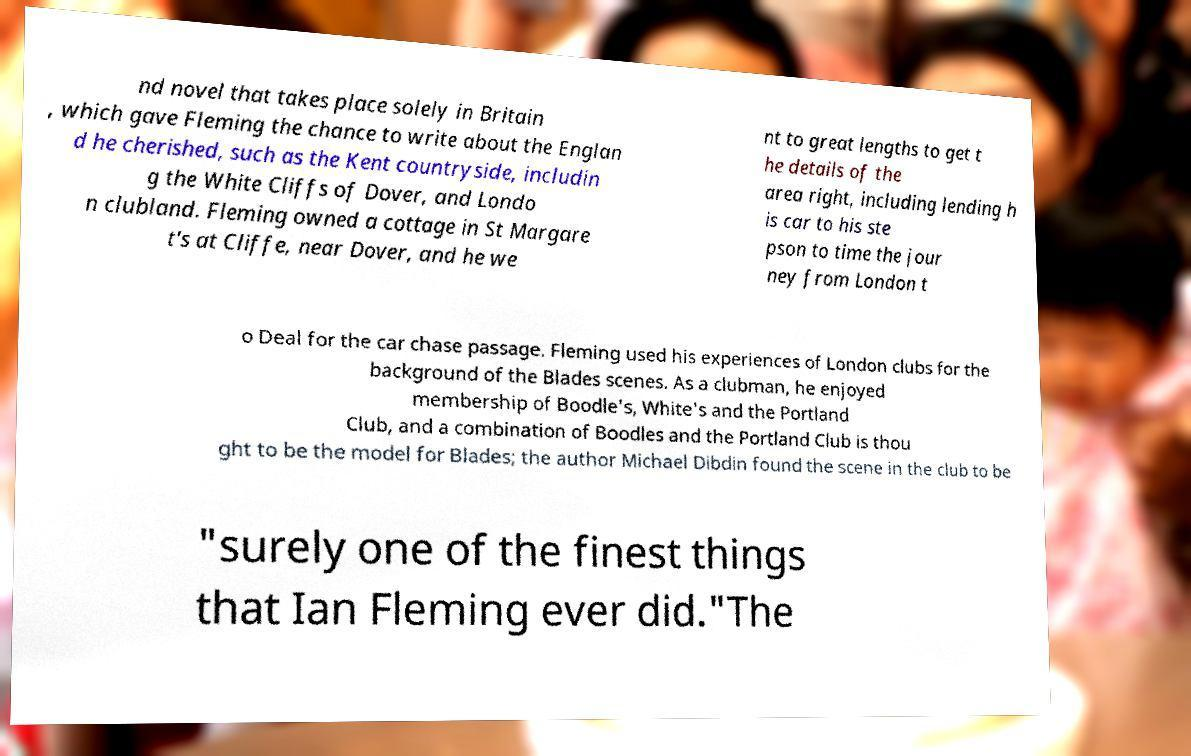Can you read and provide the text displayed in the image?This photo seems to have some interesting text. Can you extract and type it out for me? nd novel that takes place solely in Britain , which gave Fleming the chance to write about the Englan d he cherished, such as the Kent countryside, includin g the White Cliffs of Dover, and Londo n clubland. Fleming owned a cottage in St Margare t's at Cliffe, near Dover, and he we nt to great lengths to get t he details of the area right, including lending h is car to his ste pson to time the jour ney from London t o Deal for the car chase passage. Fleming used his experiences of London clubs for the background of the Blades scenes. As a clubman, he enjoyed membership of Boodle's, White's and the Portland Club, and a combination of Boodles and the Portland Club is thou ght to be the model for Blades; the author Michael Dibdin found the scene in the club to be "surely one of the finest things that Ian Fleming ever did."The 